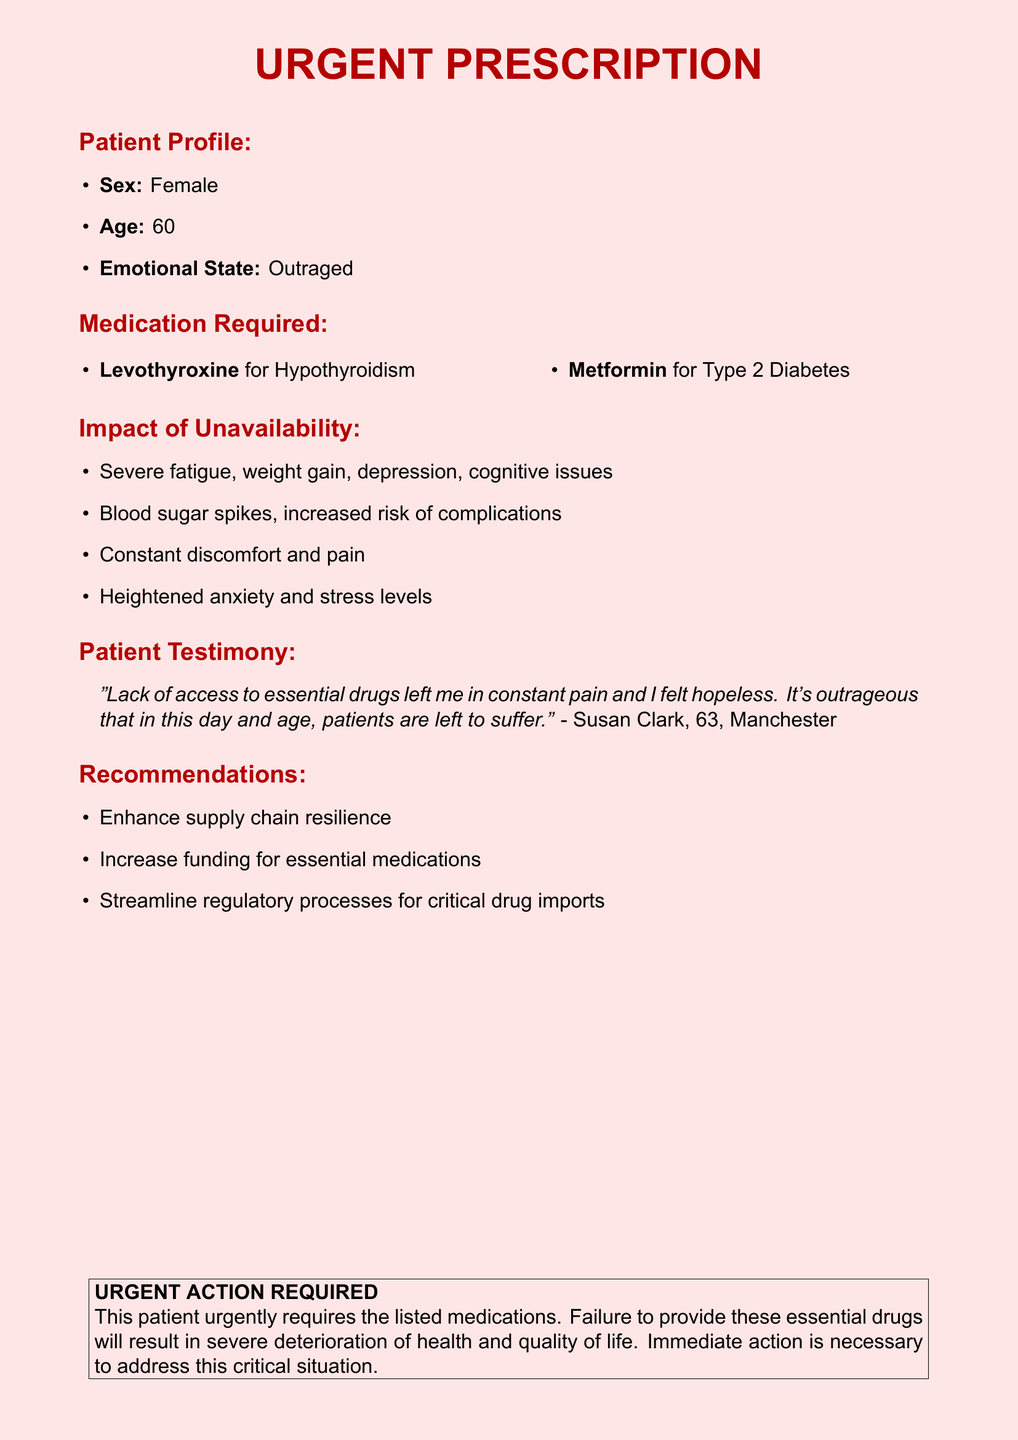what is the patient's age? The patient's age is explicitly mentioned in the document under "Patient Profile."
Answer: 60 what medications are required? The medications required are listed in the "Medication Required" section.
Answer: Levothyroxine, Metformin what emotional state is the patient in? The emotional state of the patient is included in the "Patient Profile."
Answer: Outraged what is a major consequence of medication unavailability? The consequences are listed under "Impact of Unavailability," showcasing the effects on health.
Answer: Severe fatigue who provided the patient testimony? The patient's testimony is credited to a specific individual noted in the document.
Answer: Susan Clark what is one recommendation made in the document? Recommendations are outlined, and this question asks for one of them.
Answer: Enhance supply chain resilience how does the lack of medication affect mental health? The document describes mental health effects in the "Impact of Unavailability" section.
Answer: Heightened anxiety which city is mentioned in the patient testimony? The city where the patient lives is specified in the testimony.
Answer: Manchester 